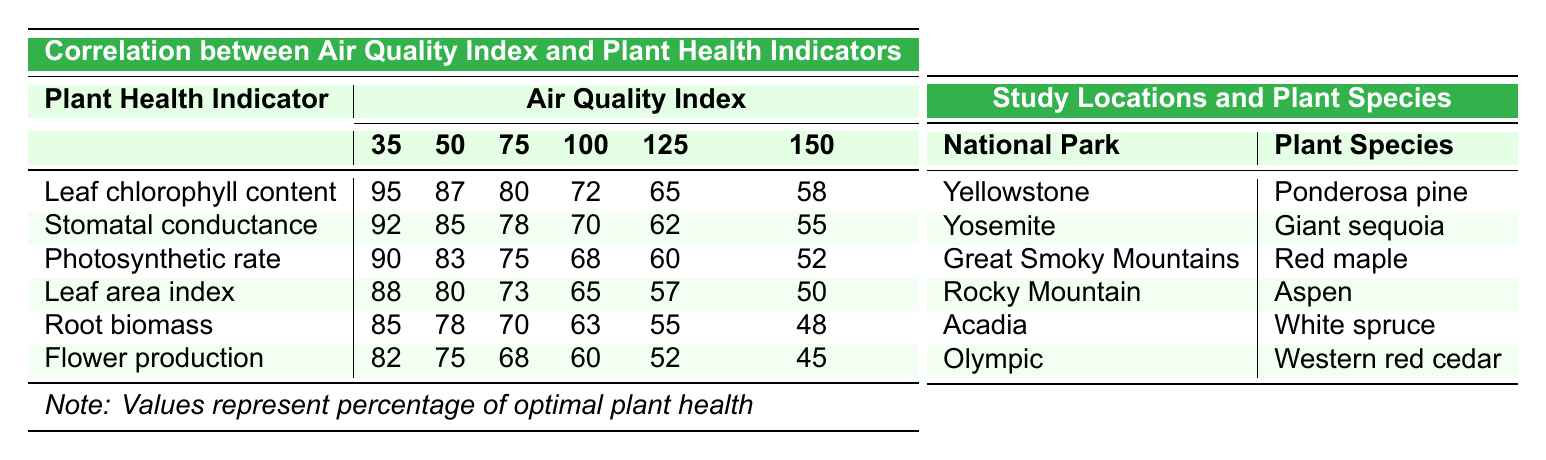What is the chlorophyll content at an air quality index of 75? From the table, we can locate the row for "Leaf chlorophyll content" and find the value corresponding to the air quality index of 75, which is 80.
Answer: 80 What is the difference in flower production between an air quality index of 35 and 150? The flower production value at an air quality index of 35 is 82, and at 150 it is 45. The difference is calculated as 82 - 45 = 37.
Answer: 37 Is the stomatal conductance higher at an air quality index of 50 than at 125? At an air quality index of 50, the stomatal conductance is 85, while at 125 it is 62. Since 85 > 62, the statement is true.
Answer: Yes What is the average leaf area index from the provided air quality indices? The leaf area index values are 88, 80, 73, 65, 57, and 50. To find the average, we sum these values (88 + 80 + 73 + 65 + 57 + 50 = 413) and then divide by 6 (413 / 6 ≈ 68.83).
Answer: 68.83 How does the photosynthetic rate change from an air quality index of 35 to 100? At an air quality index of 35, the photosynthetic rate is 90, and at 100, it is 68. The change can be determined by subtracting 68 from 90, resulting in a decrease of 22.
Answer: -22 Which health indicator shows the most significant decline from air quality index 35 to 150? We can look at each health indicator: for leaf chlorophyll content, the values decrease from 95 to 58 (loss of 37), stomatal conductance from 92 to 55 (loss of 37), photosynthetic rate from 90 to 52 (loss of 38), leaf area index from 88 to 50 (loss of 38), root biomass from 85 to 48 (loss of 37), and flower production from 82 to 45 (loss of 37). The photosynthetic rate and leaf area index both decline the most, by 38.
Answer: Photosynthetic rate and leaf area index decline the most What is the trend in plant health indicators as the air quality index increases? By observing the table, as the air quality index increases from 35 to 150, all plant health indicators show a decreasing trend, indicating poorer plant health with worsening air quality.
Answer: Decreasing trend Calculate the total root biomass across all air quality indices. The root biomass values are 85, 78, 70, 63, 55, and 48. Summing these gives: 85 + 78 + 70 + 63 + 55 + 48 = 399.
Answer: 399 